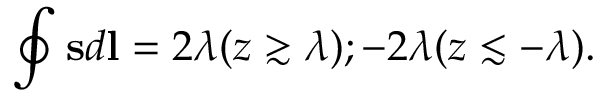Convert formula to latex. <formula><loc_0><loc_0><loc_500><loc_500>\oint s d l = 2 \lambda ( z \gtrsim \lambda ) ; - 2 \lambda ( z \lesssim - \lambda ) .</formula> 